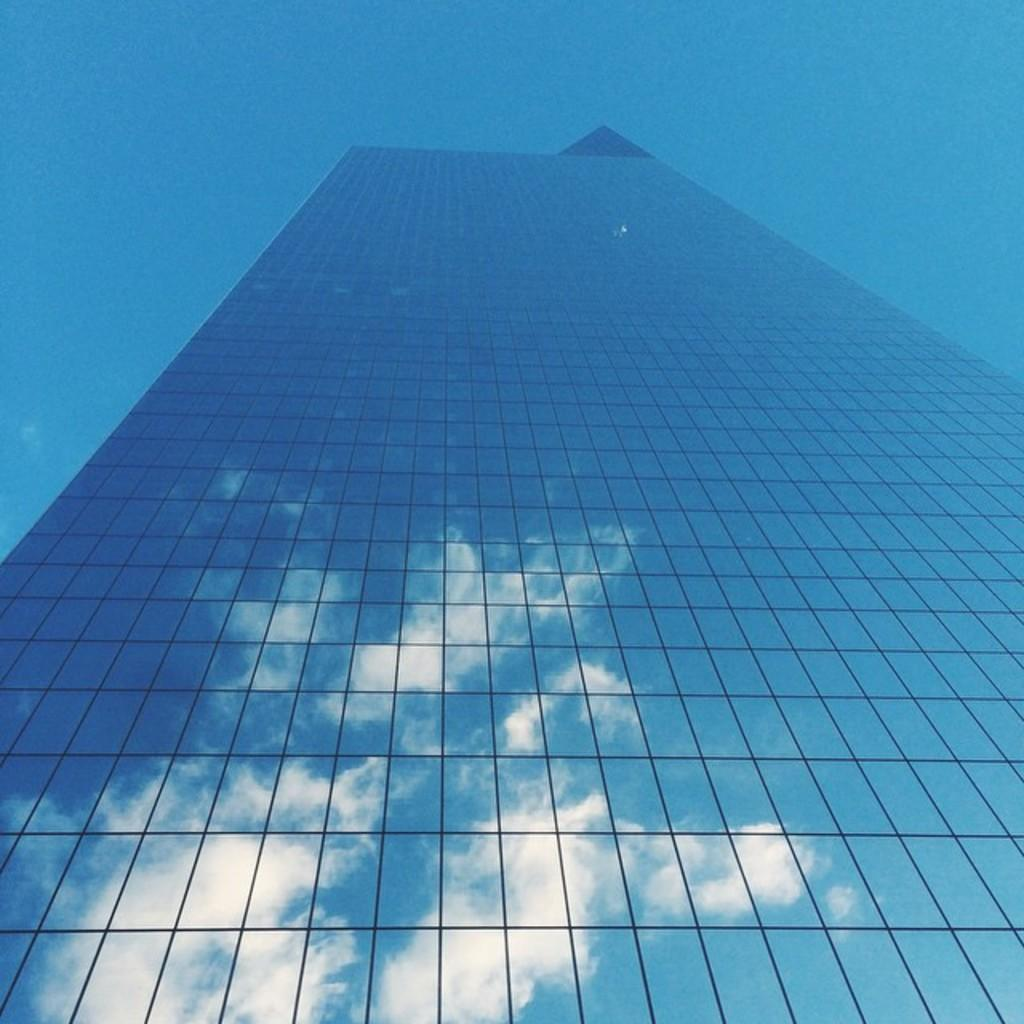What type of building is depicted in the image? There is a big glass building in the image. Can you describe any unique features of the building? The building has a reflection of clouds. What type of string is used to hold the clouds in the image? There is no string present in the image; the clouds are reflected on the surface of the building. 